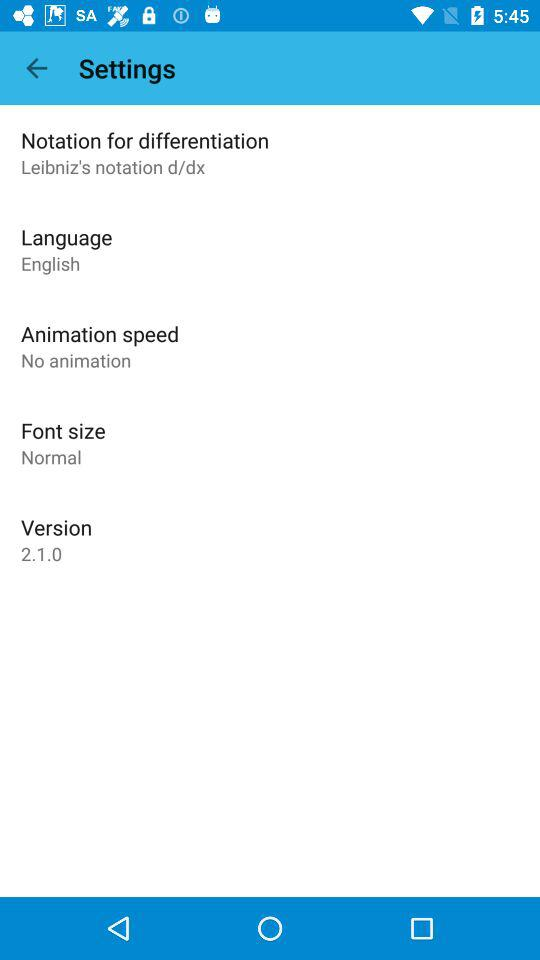How many settings options are there?
Answer the question using a single word or phrase. 5 